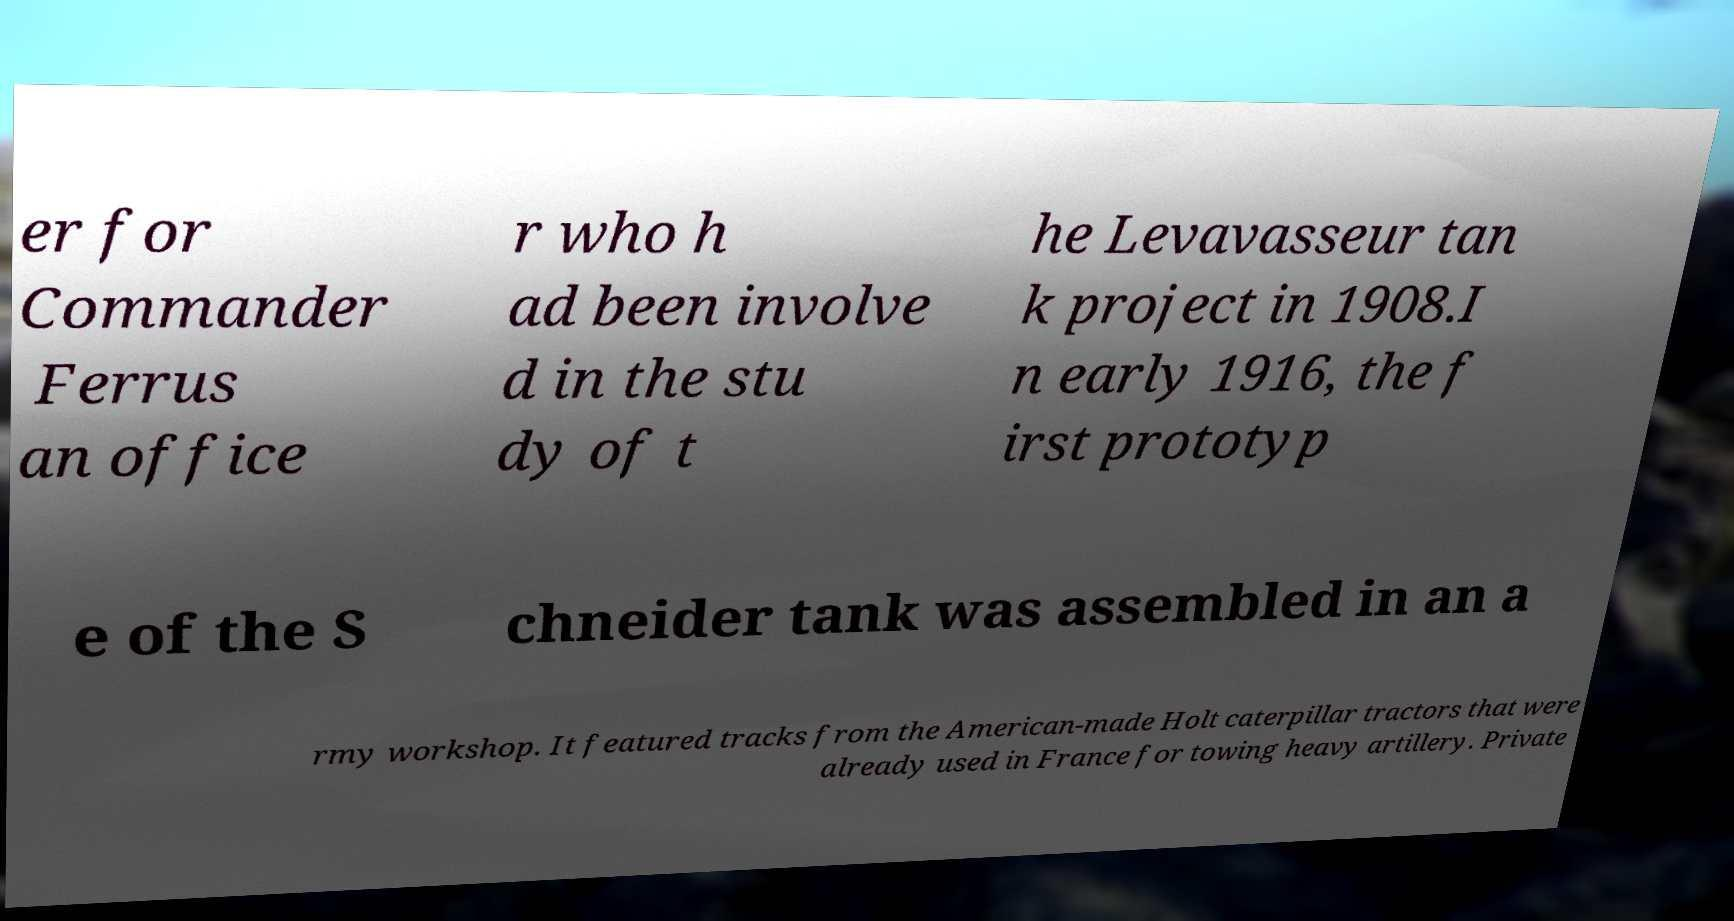Could you assist in decoding the text presented in this image and type it out clearly? er for Commander Ferrus an office r who h ad been involve d in the stu dy of t he Levavasseur tan k project in 1908.I n early 1916, the f irst prototyp e of the S chneider tank was assembled in an a rmy workshop. It featured tracks from the American-made Holt caterpillar tractors that were already used in France for towing heavy artillery. Private 